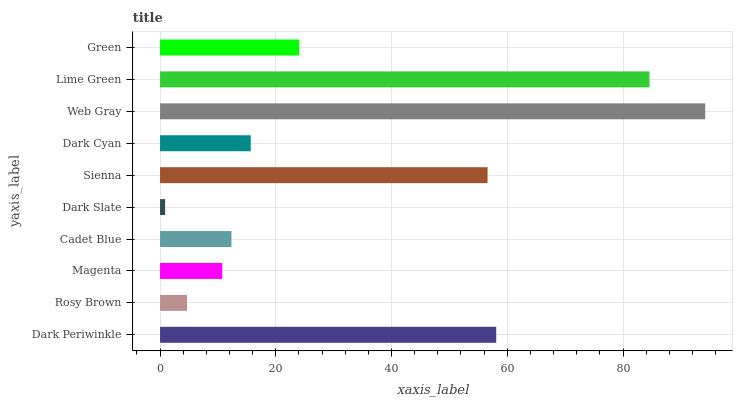Is Dark Slate the minimum?
Answer yes or no. Yes. Is Web Gray the maximum?
Answer yes or no. Yes. Is Rosy Brown the minimum?
Answer yes or no. No. Is Rosy Brown the maximum?
Answer yes or no. No. Is Dark Periwinkle greater than Rosy Brown?
Answer yes or no. Yes. Is Rosy Brown less than Dark Periwinkle?
Answer yes or no. Yes. Is Rosy Brown greater than Dark Periwinkle?
Answer yes or no. No. Is Dark Periwinkle less than Rosy Brown?
Answer yes or no. No. Is Green the high median?
Answer yes or no. Yes. Is Dark Cyan the low median?
Answer yes or no. Yes. Is Magenta the high median?
Answer yes or no. No. Is Lime Green the low median?
Answer yes or no. No. 